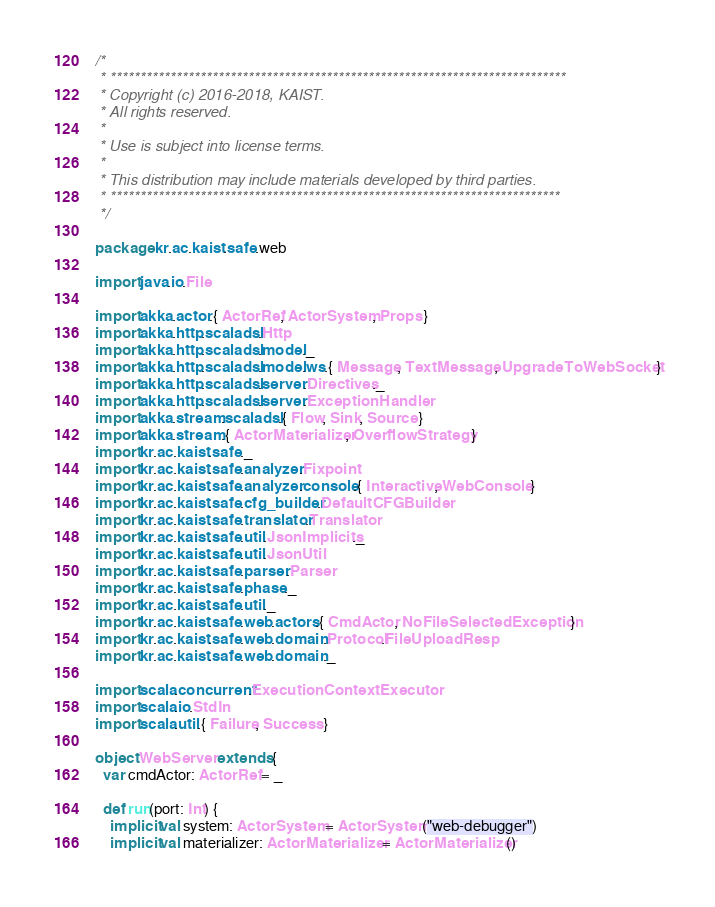<code> <loc_0><loc_0><loc_500><loc_500><_Scala_>/*
 * ****************************************************************************
 * Copyright (c) 2016-2018, KAIST.
 * All rights reserved.
 *
 * Use is subject into license terms.
 *
 * This distribution may include materials developed by third parties.
 * ***************************************************************************
 */

package kr.ac.kaist.safe.web

import java.io.File

import akka.actor.{ ActorRef, ActorSystem, Props }
import akka.http.scaladsl.Http
import akka.http.scaladsl.model._
import akka.http.scaladsl.model.ws.{ Message, TextMessage, UpgradeToWebSocket }
import akka.http.scaladsl.server.Directives._
import akka.http.scaladsl.server.ExceptionHandler
import akka.stream.scaladsl.{ Flow, Sink, Source }
import akka.stream.{ ActorMaterializer, OverflowStrategy }
import kr.ac.kaist.safe._
import kr.ac.kaist.safe.analyzer.Fixpoint
import kr.ac.kaist.safe.analyzer.console.{ Interactive, WebConsole }
import kr.ac.kaist.safe.cfg_builder.DefaultCFGBuilder
import kr.ac.kaist.safe.translator.Translator
import kr.ac.kaist.safe.util.JsonImplicits._
import kr.ac.kaist.safe.util.JsonUtil
import kr.ac.kaist.safe.parser.Parser
import kr.ac.kaist.safe.phase._
import kr.ac.kaist.safe.util._
import kr.ac.kaist.safe.web.actors.{ CmdActor, NoFileSelectedException }
import kr.ac.kaist.safe.web.domain.Protocol.FileUploadResp
import kr.ac.kaist.safe.web.domain._

import scala.concurrent.ExecutionContextExecutor
import scala.io.StdIn
import scala.util.{ Failure, Success }

object WebServer extends {
  var cmdActor: ActorRef = _

  def run(port: Int) {
    implicit val system: ActorSystem = ActorSystem("web-debugger")
    implicit val materializer: ActorMaterializer = ActorMaterializer()</code> 